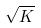<formula> <loc_0><loc_0><loc_500><loc_500>\sqrt { K }</formula> 